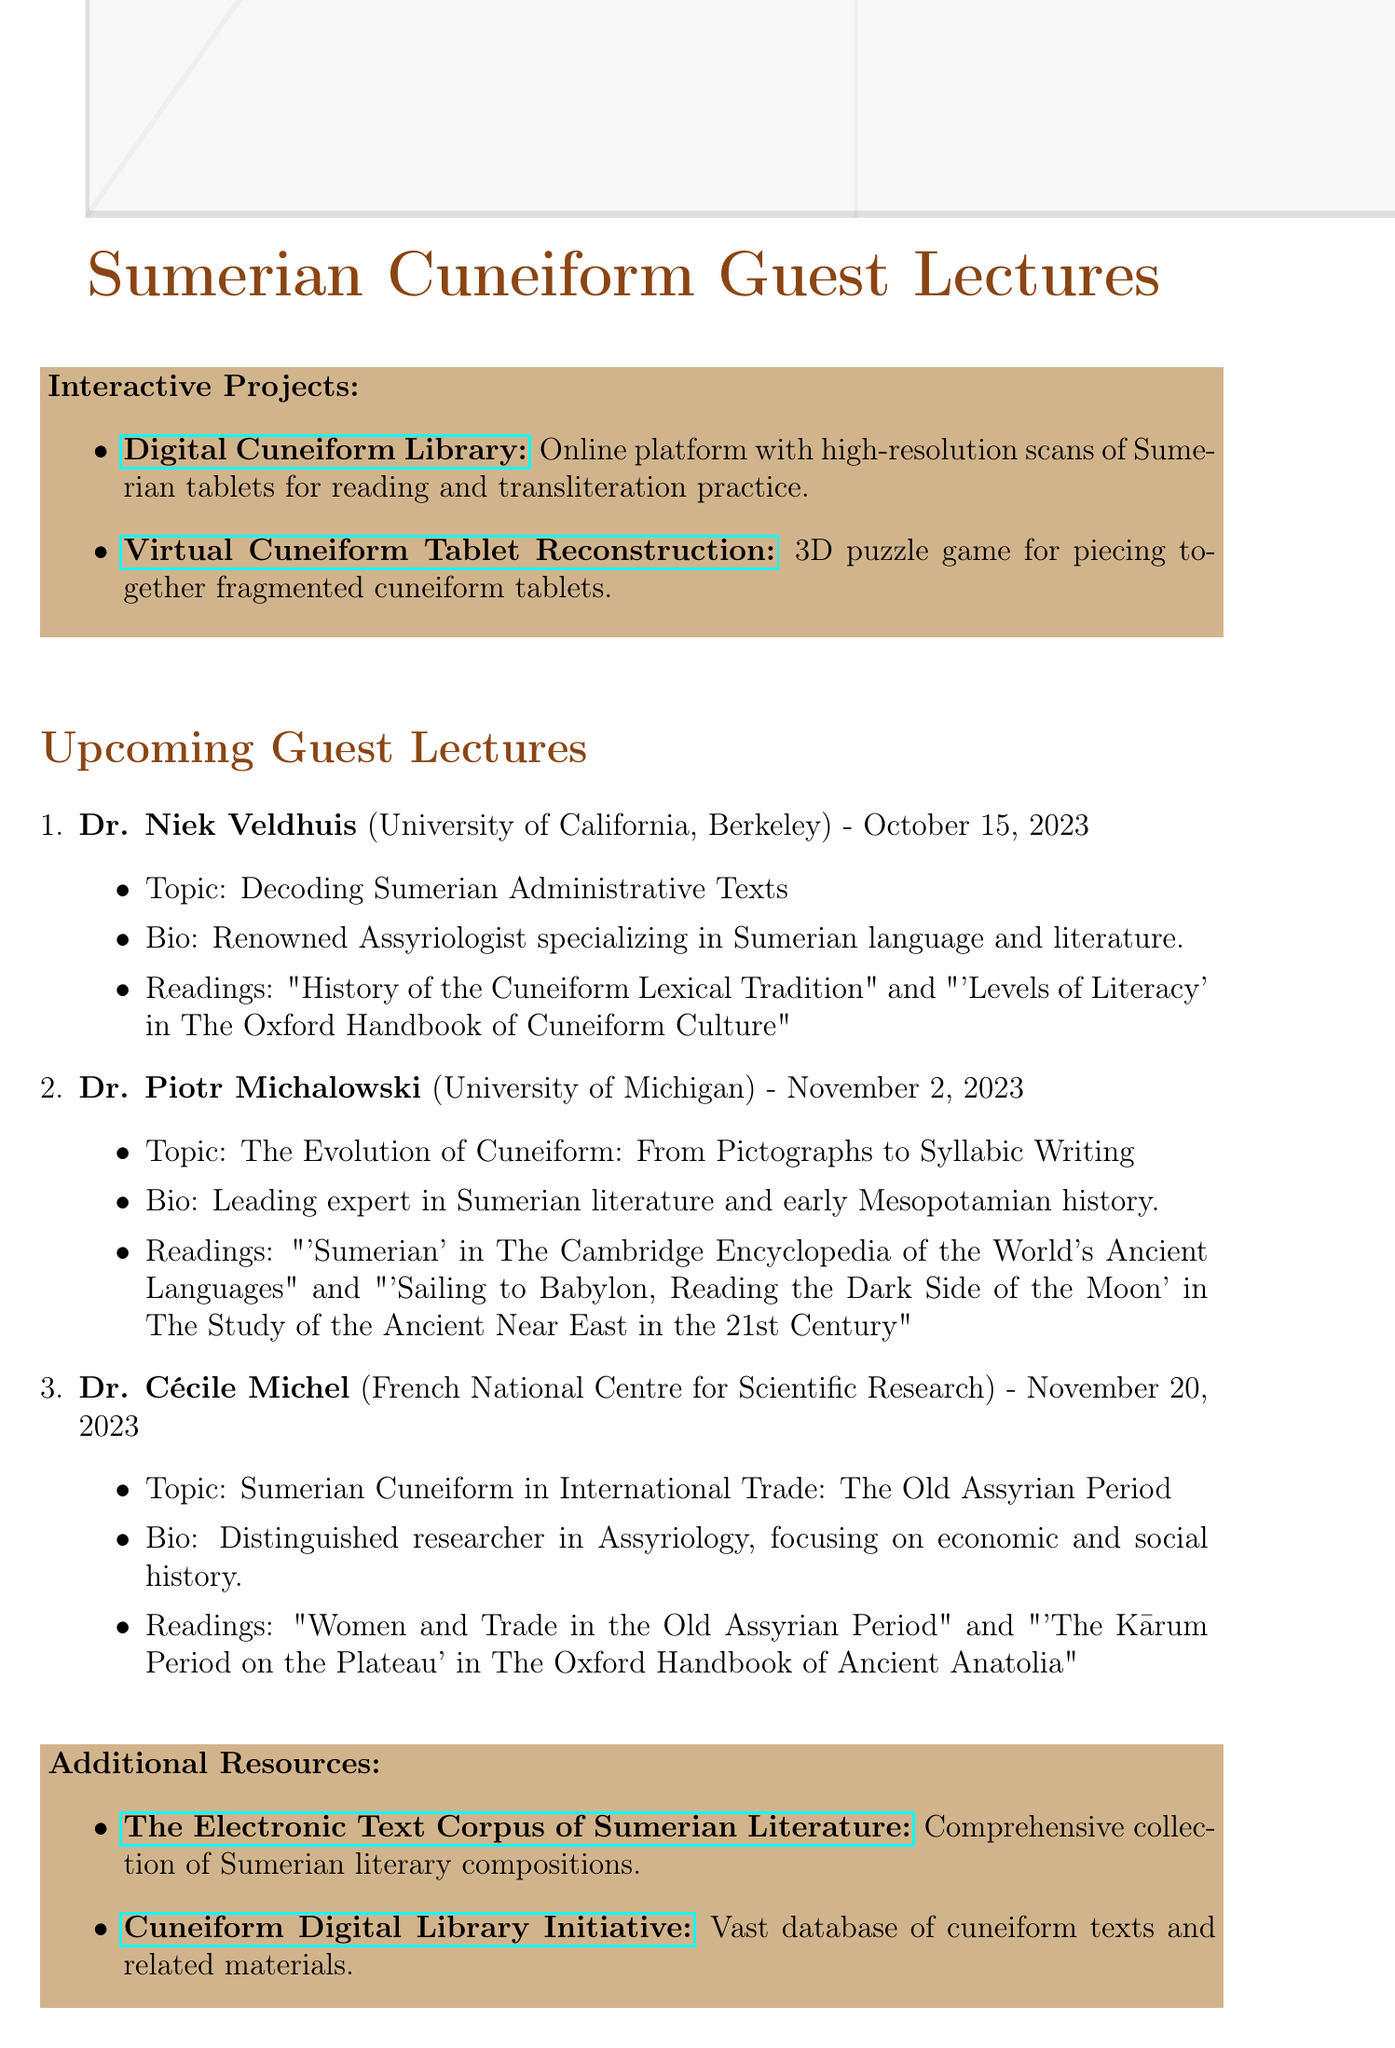What is the date of Dr. Niek Veldhuis's lecture? The date is specified in the document as October 15, 2023, corresponding to Dr. Veldhuis's lecture.
Answer: October 15, 2023 Who is affiliated with the University of Michigan? The document lists Dr. Piotr Michalowski as the speaker affiliated with the University of Michigan.
Answer: Dr. Piotr Michalowski What is the topic of Dr. Cécile Michel's lecture? The topic for Dr. Michel's lecture is detailed in the document as "Sumerian Cuneiform in International Trade: The Old Assyrian Period."
Answer: Sumerian Cuneiform in International Trade: The Old Assyrian Period Which university is Dr. Niek Veldhuis associated with? The document states that Dr. Veldhuis is affiliated with the University of California, Berkeley.
Answer: University of California, Berkeley What is one suggested reading for Dr. Piotr Michalowski's lecture? The document provides suggested readings, one being "'Sumerian' in The Cambridge Encyclopedia of the World's Ancient Languages."
Answer: 'Sumerian' in The Cambridge Encyclopedia of the World's Ancient Languages How many guest lectures on Sumerian cuneiform are mentioned in the document? The document details three guest lectures scheduled for different dates.
Answer: Three What is the title of the interactive project that focuses on reading and transliterating? The document names the project as "Digital Cuneiform Library," highlighting its purpose.
Answer: Digital Cuneiform Library Which speaker has published extensively on Sumerian lexicography? According to the document, Dr. Niek Veldhuis is noted for his extensive publications in this area.
Answer: Dr. Niek Veldhuis What is the link to the Virtual Cuneiform Tablet Reconstruction project? The document provides the URL for this project as https://virtualcuneiform.org/.
Answer: https://virtualcuneiform.org/ 